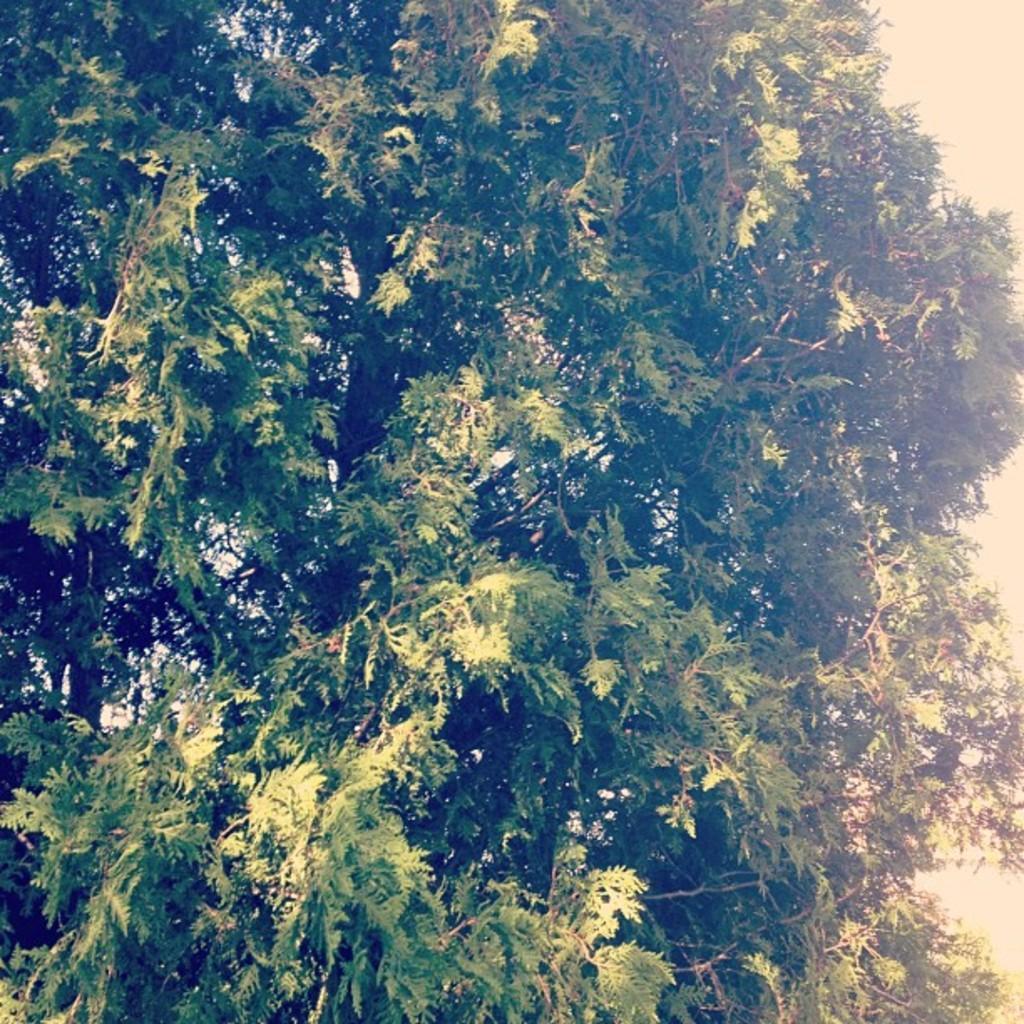Could you give a brief overview of what you see in this image? In the image there is a huge tree, it has a lot of branches. 